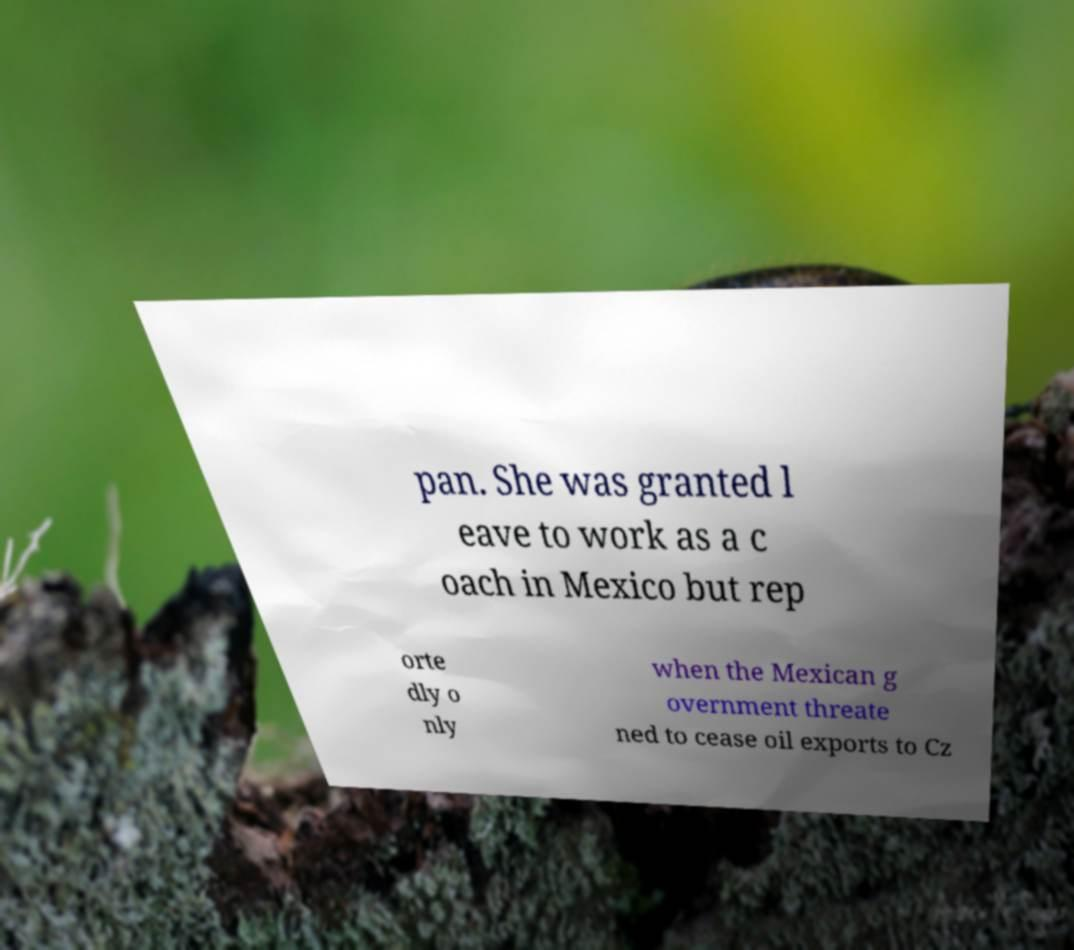What messages or text are displayed in this image? I need them in a readable, typed format. pan. She was granted l eave to work as a c oach in Mexico but rep orte dly o nly when the Mexican g overnment threate ned to cease oil exports to Cz 